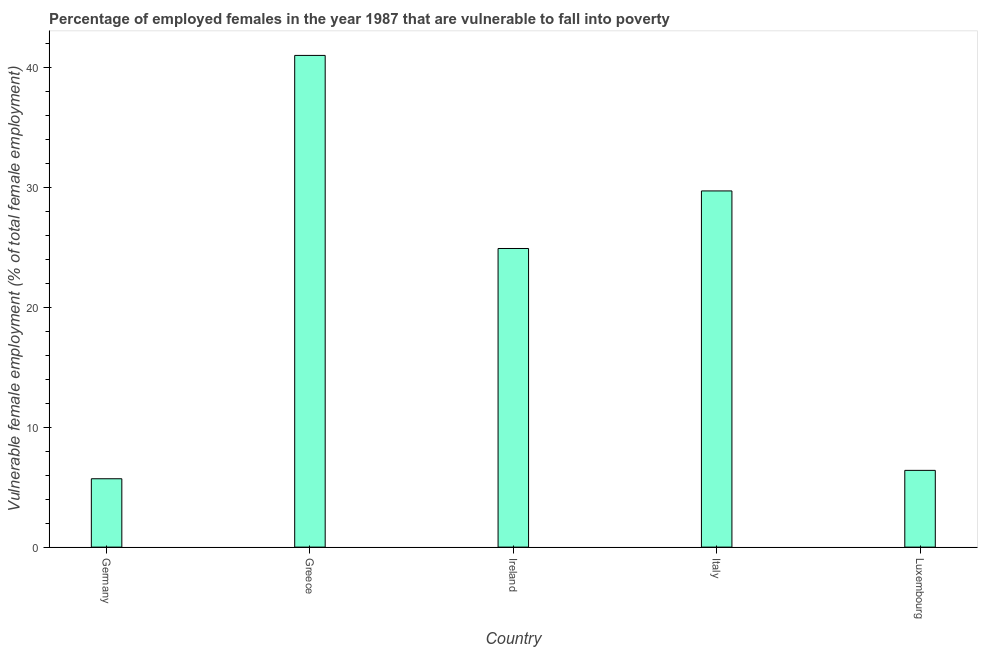Does the graph contain grids?
Your answer should be compact. No. What is the title of the graph?
Ensure brevity in your answer.  Percentage of employed females in the year 1987 that are vulnerable to fall into poverty. What is the label or title of the Y-axis?
Ensure brevity in your answer.  Vulnerable female employment (% of total female employment). What is the percentage of employed females who are vulnerable to fall into poverty in Greece?
Offer a terse response. 41. Across all countries, what is the minimum percentage of employed females who are vulnerable to fall into poverty?
Your answer should be very brief. 5.7. What is the sum of the percentage of employed females who are vulnerable to fall into poverty?
Provide a succinct answer. 107.7. What is the difference between the percentage of employed females who are vulnerable to fall into poverty in Greece and Italy?
Provide a short and direct response. 11.3. What is the average percentage of employed females who are vulnerable to fall into poverty per country?
Offer a terse response. 21.54. What is the median percentage of employed females who are vulnerable to fall into poverty?
Make the answer very short. 24.9. In how many countries, is the percentage of employed females who are vulnerable to fall into poverty greater than 8 %?
Ensure brevity in your answer.  3. What is the ratio of the percentage of employed females who are vulnerable to fall into poverty in Germany to that in Luxembourg?
Provide a short and direct response. 0.89. Is the difference between the percentage of employed females who are vulnerable to fall into poverty in Greece and Italy greater than the difference between any two countries?
Ensure brevity in your answer.  No. What is the difference between the highest and the lowest percentage of employed females who are vulnerable to fall into poverty?
Provide a short and direct response. 35.3. In how many countries, is the percentage of employed females who are vulnerable to fall into poverty greater than the average percentage of employed females who are vulnerable to fall into poverty taken over all countries?
Make the answer very short. 3. How many countries are there in the graph?
Offer a terse response. 5. What is the Vulnerable female employment (% of total female employment) of Germany?
Make the answer very short. 5.7. What is the Vulnerable female employment (% of total female employment) in Ireland?
Offer a very short reply. 24.9. What is the Vulnerable female employment (% of total female employment) of Italy?
Ensure brevity in your answer.  29.7. What is the Vulnerable female employment (% of total female employment) in Luxembourg?
Your response must be concise. 6.4. What is the difference between the Vulnerable female employment (% of total female employment) in Germany and Greece?
Keep it short and to the point. -35.3. What is the difference between the Vulnerable female employment (% of total female employment) in Germany and Ireland?
Provide a short and direct response. -19.2. What is the difference between the Vulnerable female employment (% of total female employment) in Germany and Italy?
Provide a short and direct response. -24. What is the difference between the Vulnerable female employment (% of total female employment) in Greece and Ireland?
Provide a succinct answer. 16.1. What is the difference between the Vulnerable female employment (% of total female employment) in Greece and Luxembourg?
Keep it short and to the point. 34.6. What is the difference between the Vulnerable female employment (% of total female employment) in Italy and Luxembourg?
Your response must be concise. 23.3. What is the ratio of the Vulnerable female employment (% of total female employment) in Germany to that in Greece?
Make the answer very short. 0.14. What is the ratio of the Vulnerable female employment (% of total female employment) in Germany to that in Ireland?
Keep it short and to the point. 0.23. What is the ratio of the Vulnerable female employment (% of total female employment) in Germany to that in Italy?
Make the answer very short. 0.19. What is the ratio of the Vulnerable female employment (% of total female employment) in Germany to that in Luxembourg?
Give a very brief answer. 0.89. What is the ratio of the Vulnerable female employment (% of total female employment) in Greece to that in Ireland?
Offer a very short reply. 1.65. What is the ratio of the Vulnerable female employment (% of total female employment) in Greece to that in Italy?
Give a very brief answer. 1.38. What is the ratio of the Vulnerable female employment (% of total female employment) in Greece to that in Luxembourg?
Your answer should be compact. 6.41. What is the ratio of the Vulnerable female employment (% of total female employment) in Ireland to that in Italy?
Offer a terse response. 0.84. What is the ratio of the Vulnerable female employment (% of total female employment) in Ireland to that in Luxembourg?
Provide a succinct answer. 3.89. What is the ratio of the Vulnerable female employment (% of total female employment) in Italy to that in Luxembourg?
Provide a short and direct response. 4.64. 